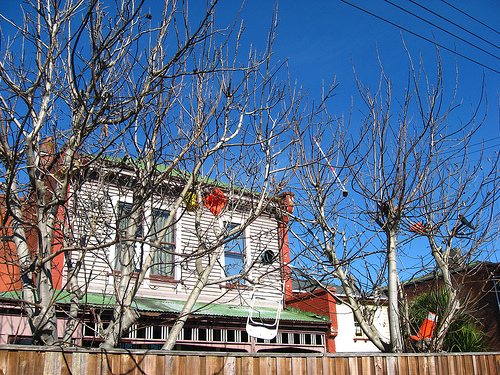<image>
Is there a chair in the tree? Yes. The chair is contained within or inside the tree, showing a containment relationship. 